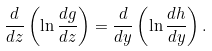Convert formula to latex. <formula><loc_0><loc_0><loc_500><loc_500>\frac { d } { d z } \left ( \ln { \frac { d g } { d z } } \right ) = \frac { d } { d y } \left ( \ln { \frac { d h } { d y } } \right ) .</formula> 